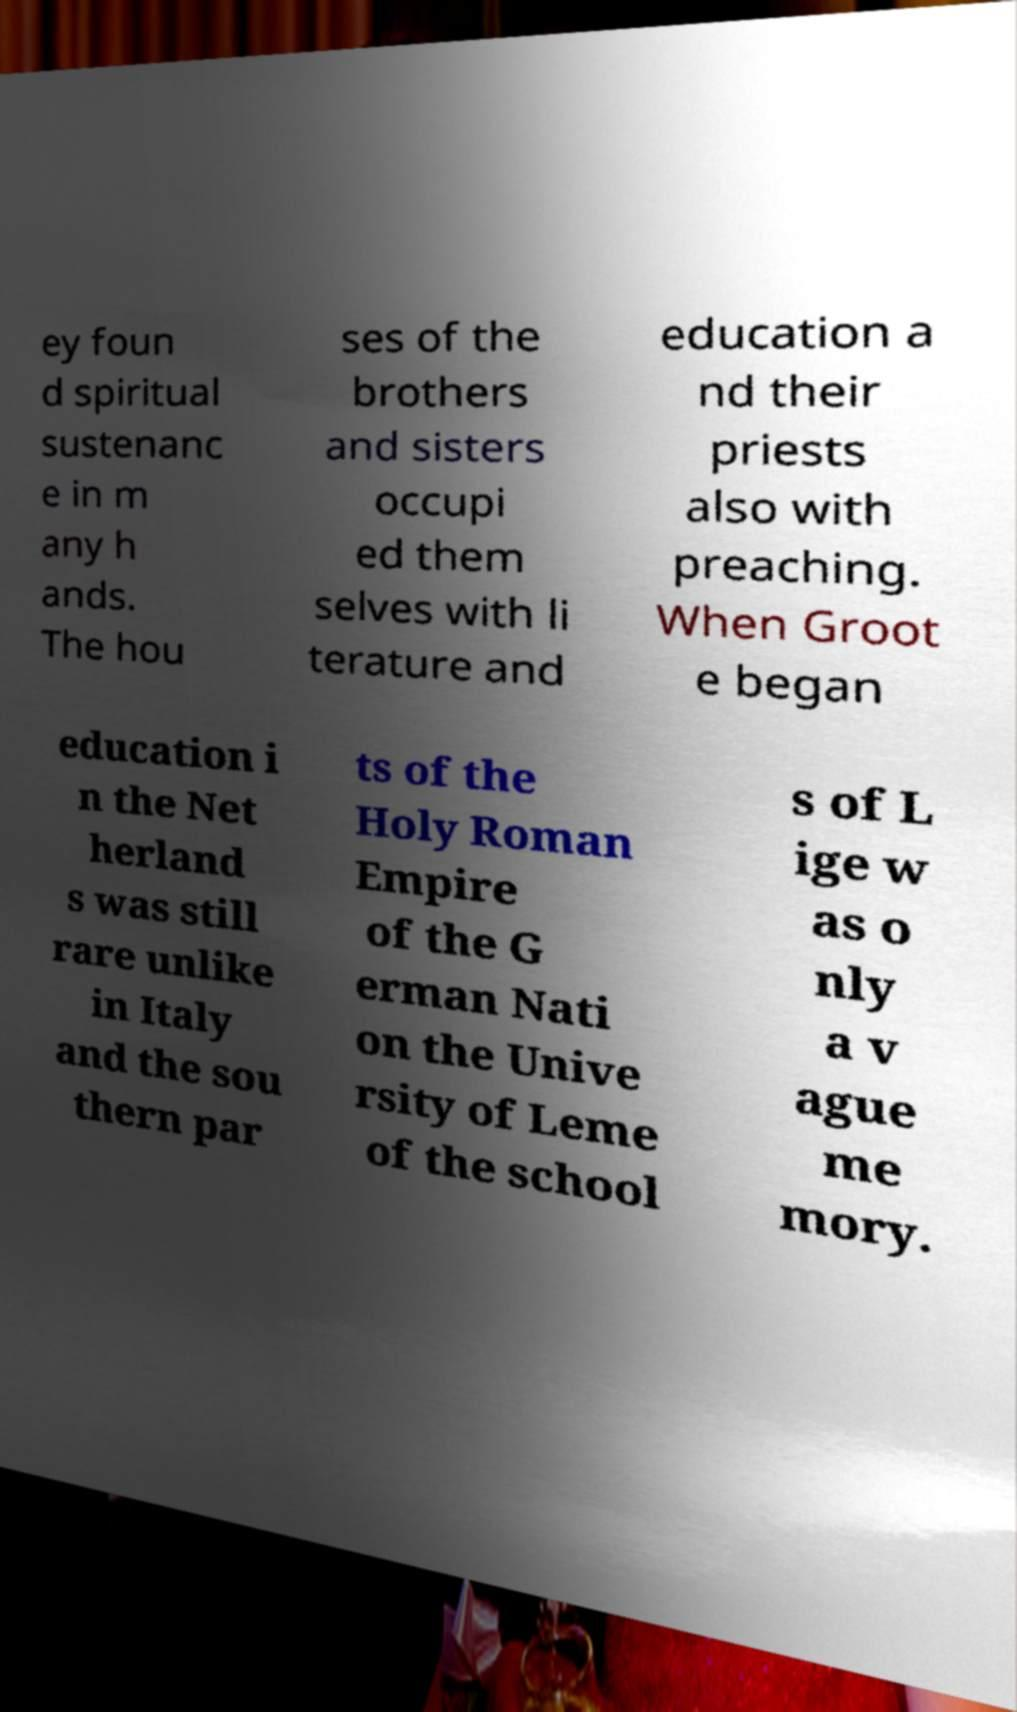Could you assist in decoding the text presented in this image and type it out clearly? ey foun d spiritual sustenanc e in m any h ands. The hou ses of the brothers and sisters occupi ed them selves with li terature and education a nd their priests also with preaching. When Groot e began education i n the Net herland s was still rare unlike in Italy and the sou thern par ts of the Holy Roman Empire of the G erman Nati on the Unive rsity of Leme of the school s of L ige w as o nly a v ague me mory. 